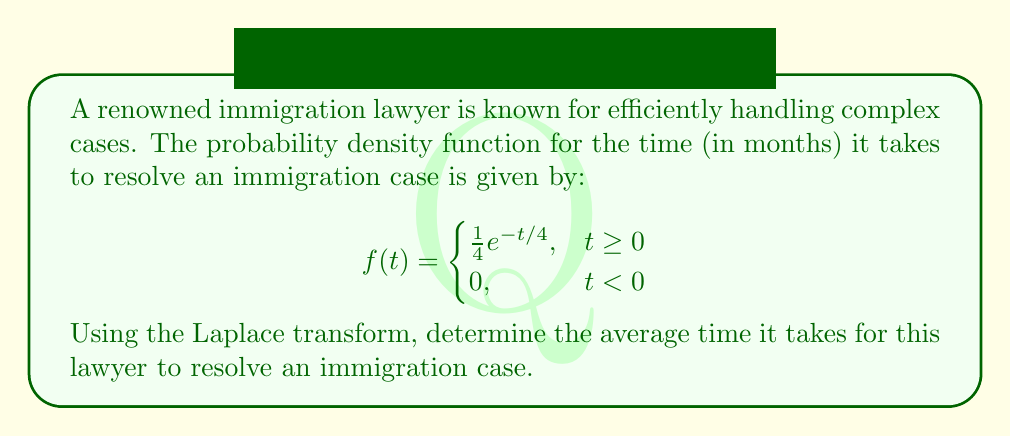Show me your answer to this math problem. To solve this problem, we'll use the Laplace transform and its properties. Let's approach this step-by-step:

1) The average (or expected value) of a continuous random variable T is given by:

   $$E[T] = \int_0^{\infty} t f(t) dt$$

2) We can relate this to the Laplace transform. Recall that the Laplace transform of f(t) is defined as:

   $$F(s) = \mathcal{L}\{f(t)\} = \int_0^{\infty} e^{-st} f(t) dt$$

3) A key property of the Laplace transform is that:

   $$E[T] = -\frac{d}{ds}F(s)\bigg|_{s=0}$$

4) Let's first find the Laplace transform of our given function:

   $$F(s) = \int_0^{\infty} e^{-st} \cdot \frac{1}{4}e^{-t/4} dt = \frac{1}{4} \int_0^{\infty} e^{-(s+1/4)t} dt$$

5) Evaluating this integral:

   $$F(s) = \frac{1}{4} \cdot \frac{1}{s+1/4} = \frac{1}{4s+1}$$

6) Now, let's find the derivative of F(s):

   $$\frac{d}{ds}F(s) = -\frac{4}{(4s+1)^2}$$

7) Evaluating this at s = 0:

   $$-\frac{d}{ds}F(s)\bigg|_{s=0} = \frac{4}{(4\cdot0+1)^2} = 4$$

Therefore, the average time it takes for this lawyer to resolve an immigration case is 4 months.
Answer: 4 months 